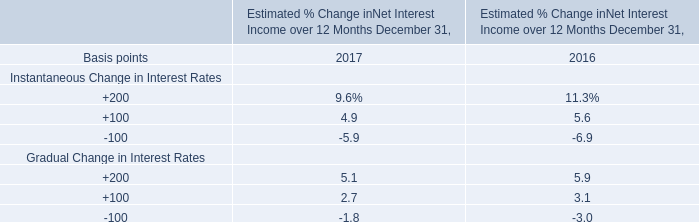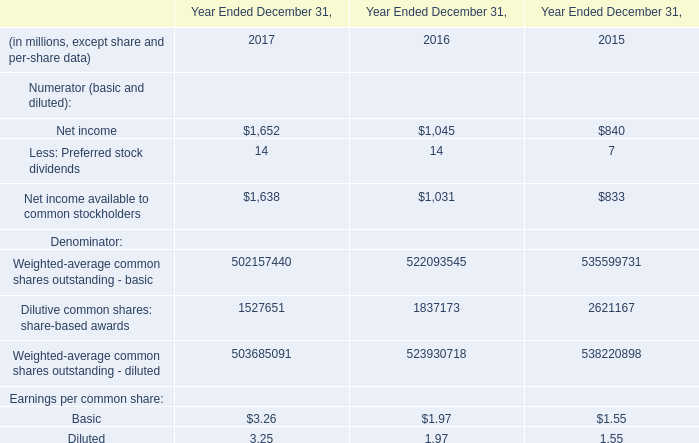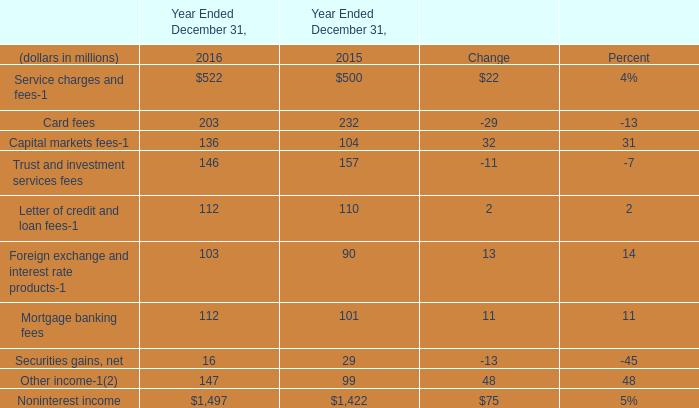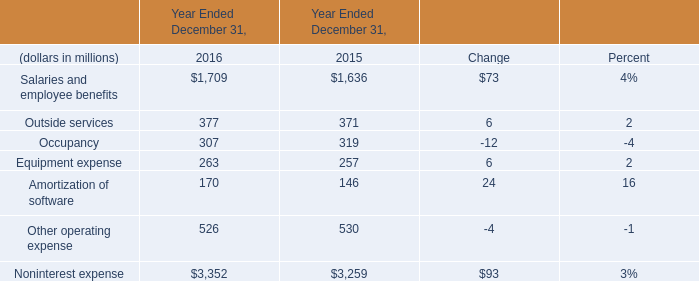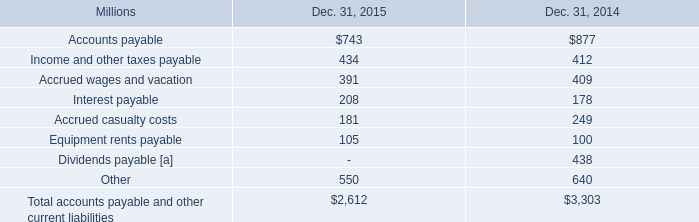What's the growth rate of Salaries and employee benefits in 2016? 
Computations: ((1709 - 1636) / 1636)
Answer: 0.04462. 